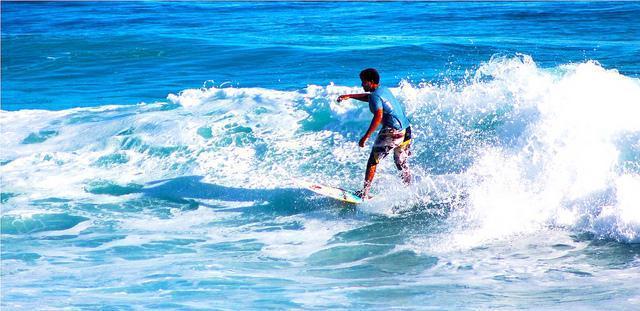How many people are riding boards?
Give a very brief answer. 1. 